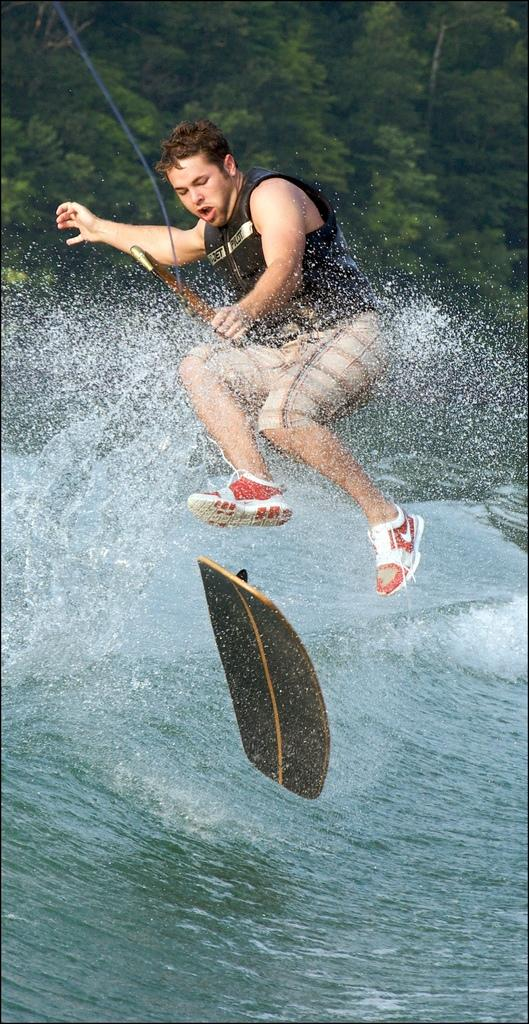What is the man in the image doing? The man is surfing on the waves. What type of clothing is the man wearing on his feet? The man is wearing sports shoes. What color is the shirt the man is wearing? The man is wearing a black shirt. What type of pants is the man wearing? The man is wearing a short. What is the man using for additional support while surfing? The man is holding a rope for support. What type of crush does the man have on the woman in the image? There is no woman present in the image, so it is not possible to determine if the man has a crush on anyone. 